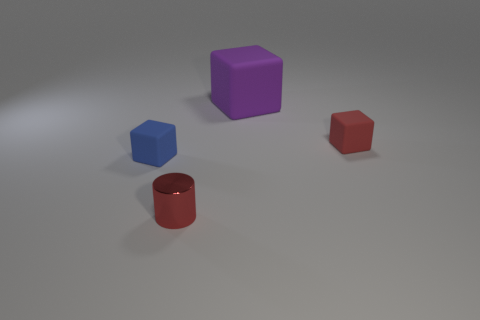Is there anything else that has the same material as the cylinder?
Your response must be concise. No. What number of large purple rubber cylinders are there?
Offer a terse response. 0. What number of spheres are purple rubber things or tiny red rubber objects?
Your response must be concise. 0. There is a block to the left of the red cylinder; how many tiny cylinders are left of it?
Keep it short and to the point. 0. Does the big thing have the same material as the tiny cylinder?
Your response must be concise. No. What size is the block that is the same color as the tiny cylinder?
Ensure brevity in your answer.  Small. Are there any blocks made of the same material as the small cylinder?
Ensure brevity in your answer.  No. What is the color of the small matte object that is behind the tiny rubber object in front of the small cube right of the purple object?
Give a very brief answer. Red. How many yellow objects are either metal cylinders or rubber cubes?
Provide a short and direct response. 0. What number of tiny rubber objects are the same shape as the metallic object?
Make the answer very short. 0. 